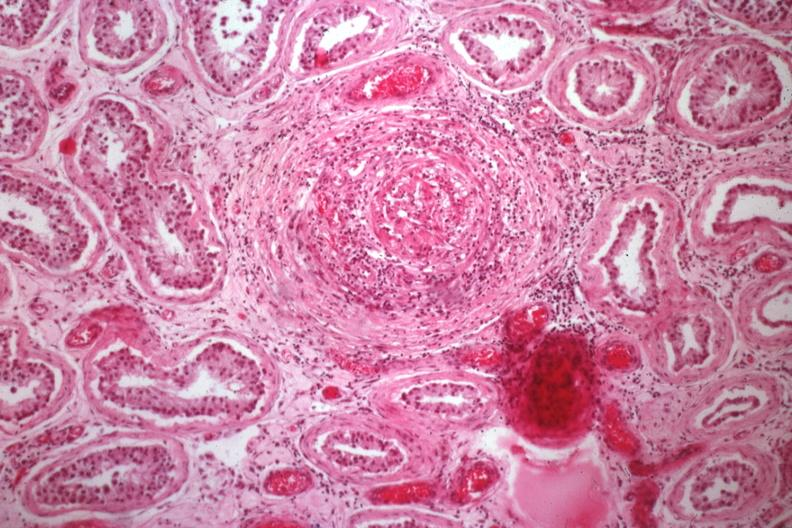what is present?
Answer the question using a single word or phrase. Testicle 